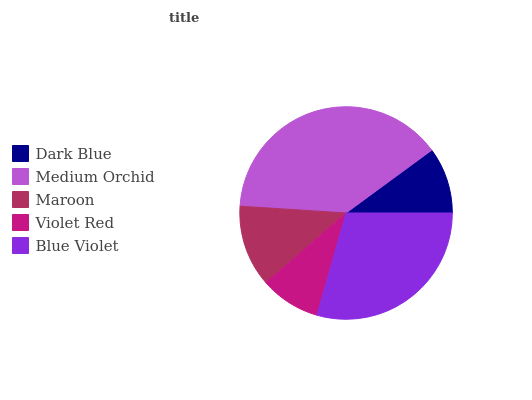Is Violet Red the minimum?
Answer yes or no. Yes. Is Medium Orchid the maximum?
Answer yes or no. Yes. Is Maroon the minimum?
Answer yes or no. No. Is Maroon the maximum?
Answer yes or no. No. Is Medium Orchid greater than Maroon?
Answer yes or no. Yes. Is Maroon less than Medium Orchid?
Answer yes or no. Yes. Is Maroon greater than Medium Orchid?
Answer yes or no. No. Is Medium Orchid less than Maroon?
Answer yes or no. No. Is Maroon the high median?
Answer yes or no. Yes. Is Maroon the low median?
Answer yes or no. Yes. Is Medium Orchid the high median?
Answer yes or no. No. Is Violet Red the low median?
Answer yes or no. No. 